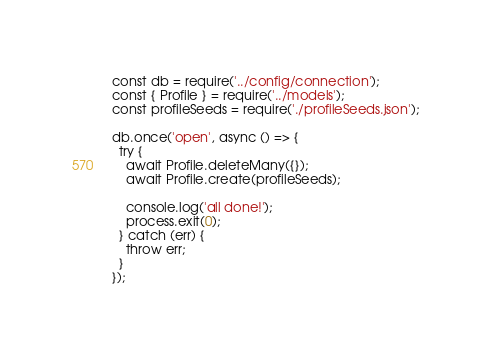<code> <loc_0><loc_0><loc_500><loc_500><_JavaScript_>const db = require('../config/connection');
const { Profile } = require('../models');
const profileSeeds = require('./profileSeeds.json');

db.once('open', async () => {
  try {
    await Profile.deleteMany({});
    await Profile.create(profileSeeds);

    console.log('all done!');
    process.exit(0);
  } catch (err) {
    throw err;
  }
});
</code> 